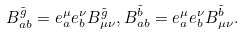Convert formula to latex. <formula><loc_0><loc_0><loc_500><loc_500>B _ { a b } ^ { \tilde { g } } = e _ { a } ^ { \mu } e _ { b } ^ { \nu } B _ { \mu \nu } ^ { \tilde { g } } , B _ { a b } ^ { \tilde { b } } = e _ { a } ^ { \mu } e _ { b } ^ { \nu } B _ { \mu \nu } ^ { \tilde { b } } .</formula> 